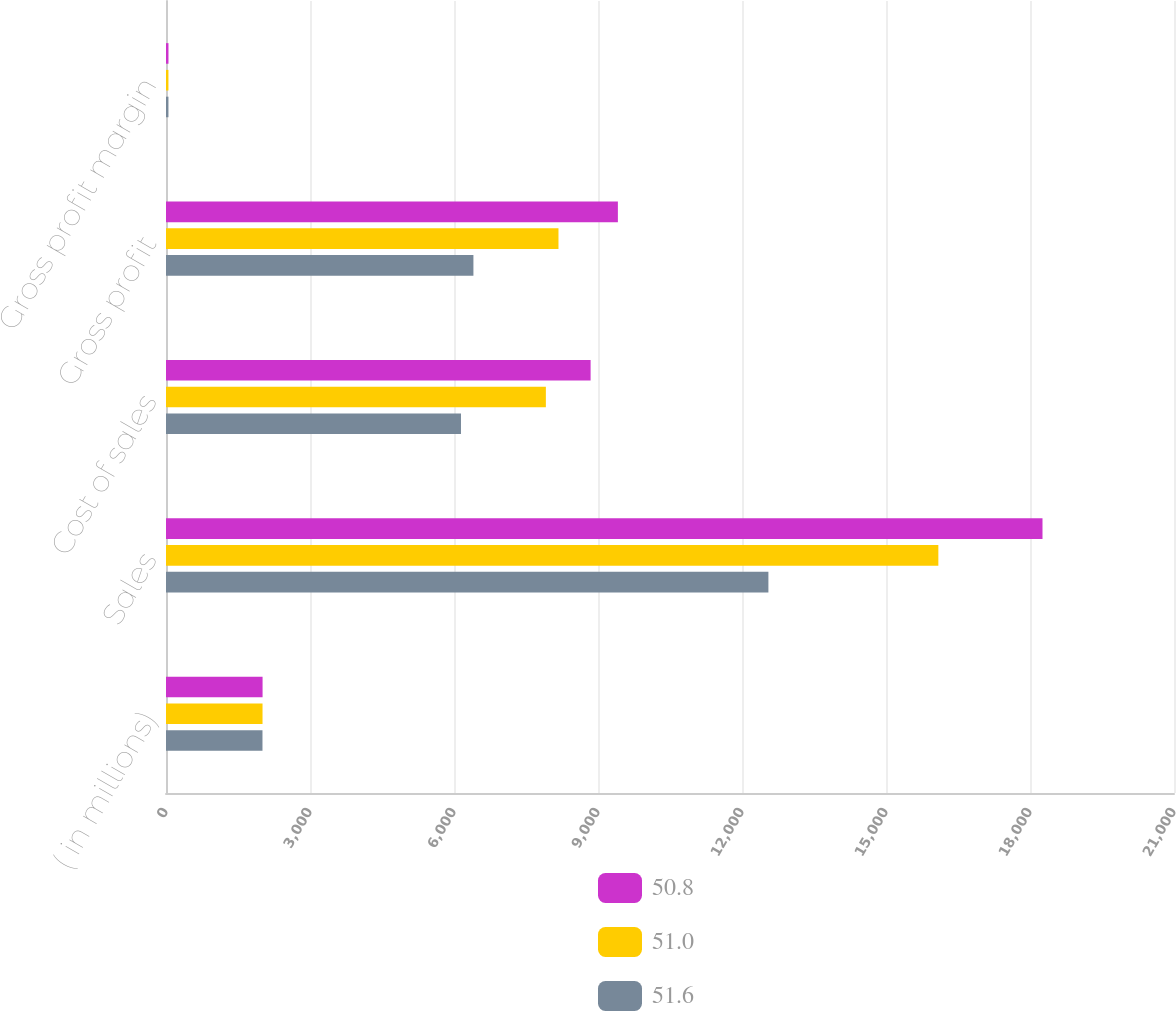<chart> <loc_0><loc_0><loc_500><loc_500><stacked_bar_chart><ecel><fcel>( in millions)<fcel>Sales<fcel>Cost of sales<fcel>Gross profit<fcel>Gross profit margin<nl><fcel>50.8<fcel>2012<fcel>18260.4<fcel>8846.1<fcel>9414.3<fcel>51.6<nl><fcel>51<fcel>2011<fcel>16090.5<fcel>7913.9<fcel>8176.6<fcel>50.8<nl><fcel>51.6<fcel>2010<fcel>12550<fcel>6145.5<fcel>6404.5<fcel>51<nl></chart> 